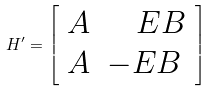Convert formula to latex. <formula><loc_0><loc_0><loc_500><loc_500>H ^ { \prime } = \left [ \begin{array} { l l } A & { \quad } E B \\ A & - E B \\ \end{array} \right ]</formula> 